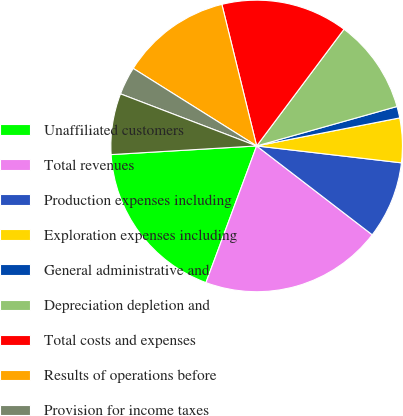<chart> <loc_0><loc_0><loc_500><loc_500><pie_chart><fcel>Unaffiliated customers<fcel>Total revenues<fcel>Production expenses including<fcel>Exploration expenses including<fcel>General administrative and<fcel>Depreciation depletion and<fcel>Total costs and expenses<fcel>Results of operations before<fcel>Provision for income taxes<fcel>Results of operations<nl><fcel>18.4%<fcel>20.22%<fcel>8.58%<fcel>4.93%<fcel>1.28%<fcel>10.41%<fcel>14.06%<fcel>12.24%<fcel>3.11%<fcel>6.76%<nl></chart> 